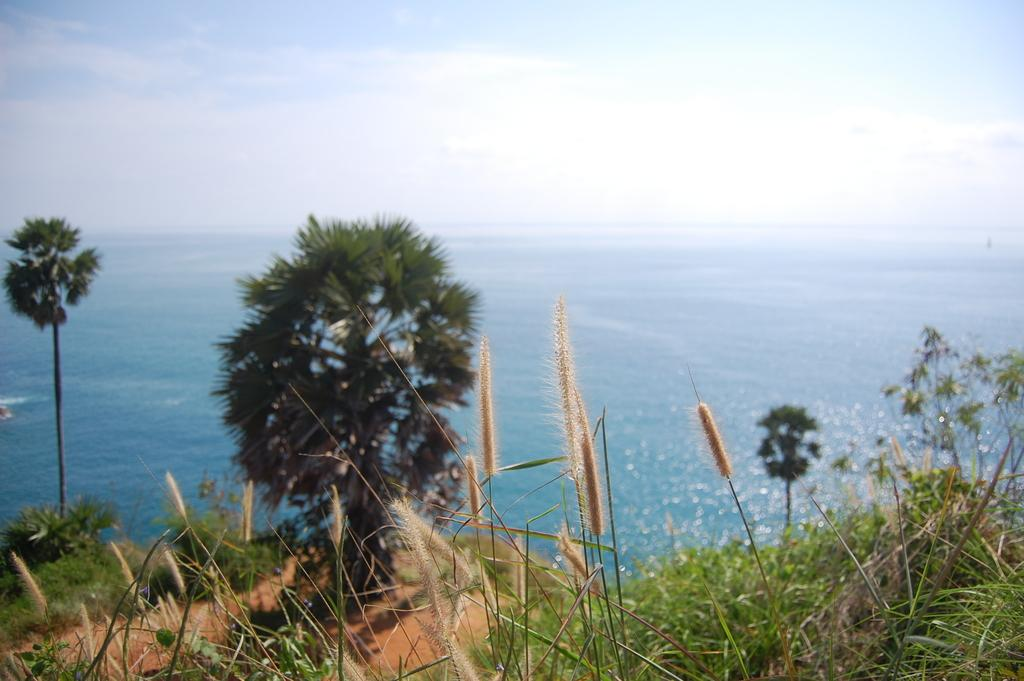What type of vegetation can be seen in the foreground of the image? There is green grass in the foreground of the image. What other natural elements are visible in the image? Trees and water are visible in the image. What is the condition of the sky in the image? Clouds are present in the sky in the image. What type of hat is the duck wearing in the image? There is no duck or hat present in the image. What is the zephyr's role in the image? There is no zephyr mentioned or depicted in the image. 